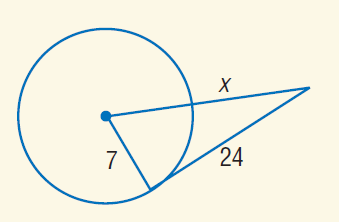Answer the mathemtical geometry problem and directly provide the correct option letter.
Question: Find x. Assume that segments that appear to be tangent are tangent.
Choices: A: 3 B: 7 C: 18 D: 24 C 